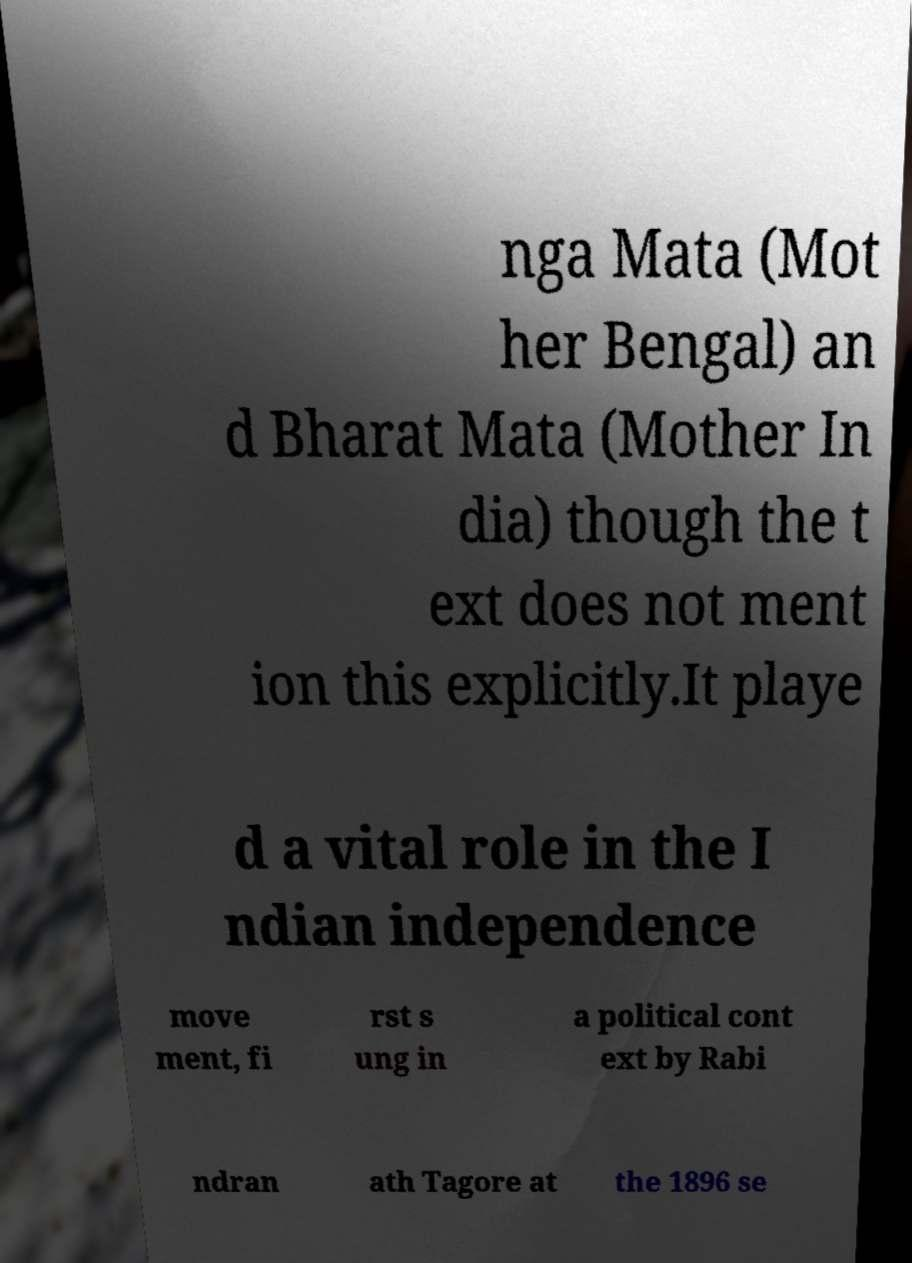Please identify and transcribe the text found in this image. nga Mata (Mot her Bengal) an d Bharat Mata (Mother In dia) though the t ext does not ment ion this explicitly.It playe d a vital role in the I ndian independence move ment, fi rst s ung in a political cont ext by Rabi ndran ath Tagore at the 1896 se 